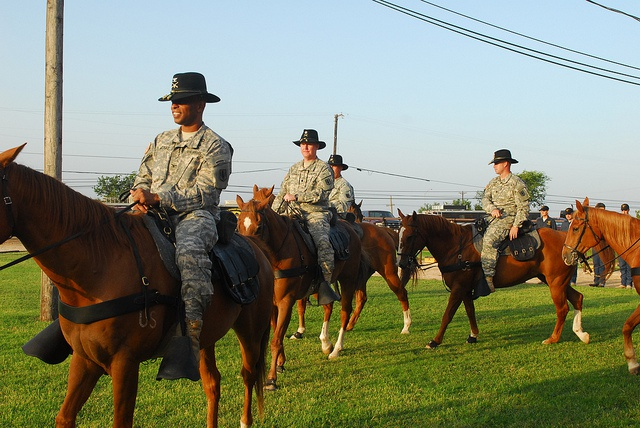Describe the objects in this image and their specific colors. I can see horse in lightblue, black, maroon, brown, and olive tones, people in lightblue, black, gray, and tan tones, horse in lightblue, black, maroon, and olive tones, horse in lightblue, black, brown, maroon, and olive tones, and people in lightblue, black, gray, and tan tones in this image. 